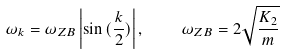<formula> <loc_0><loc_0><loc_500><loc_500>\omega _ { k } = \omega _ { Z B } \left | \sin { ( \frac { k } { 2 } ) } \right | , \quad \omega _ { Z B } = 2 \sqrt { \frac { K _ { 2 } } { m } }</formula> 